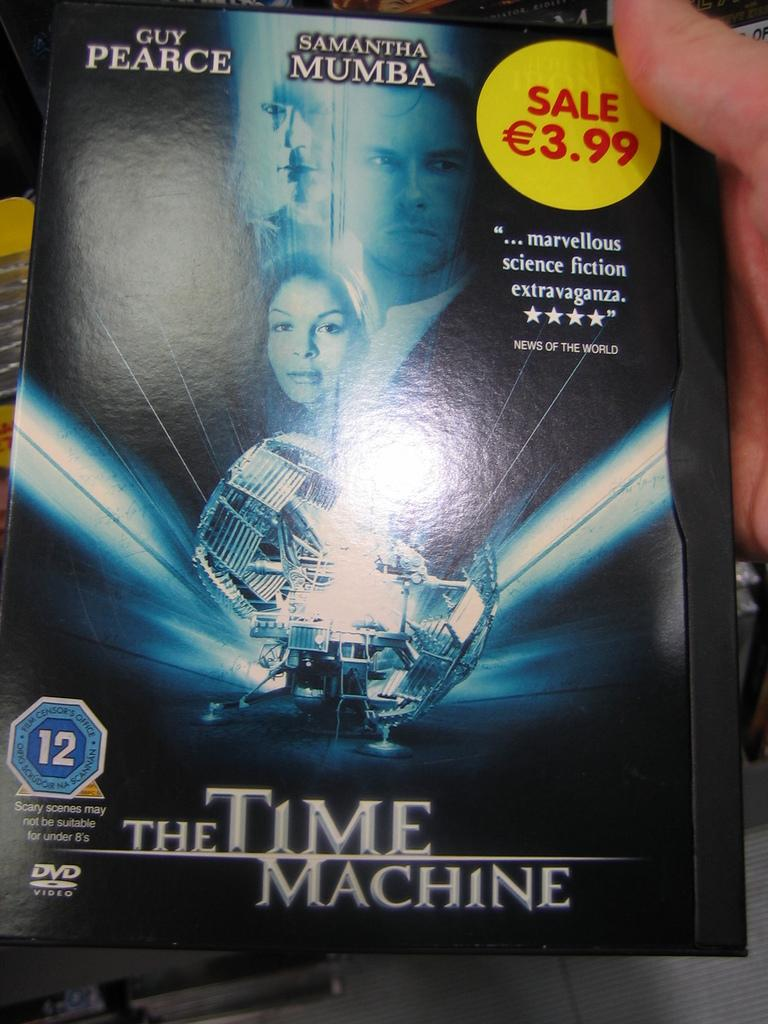<image>
Provide a brief description of the given image. The DVD for the Time Machine by Guy Pearce. 